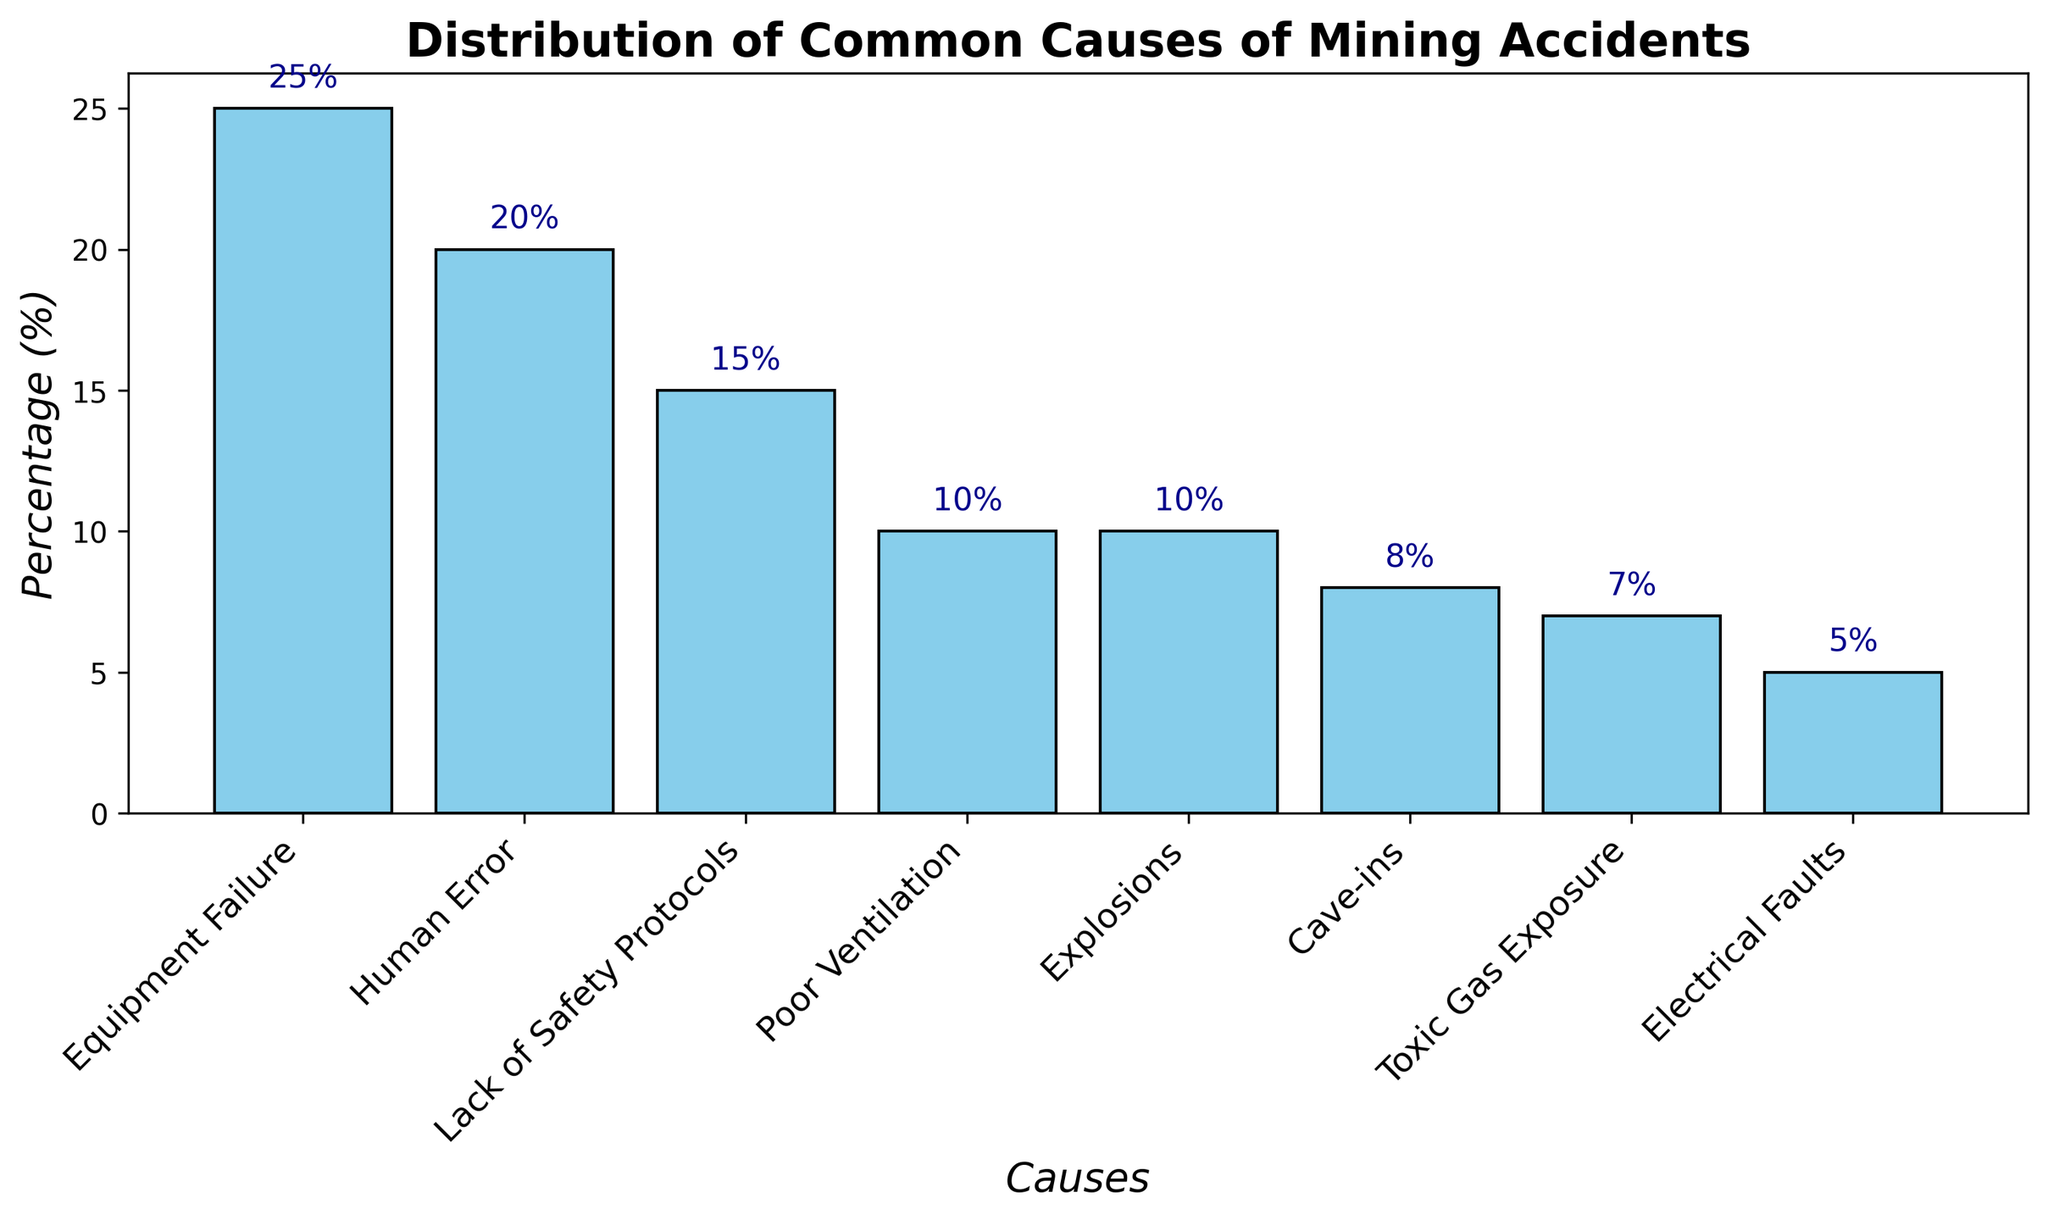Which cause has the highest percentage of mining accidents? Looking at the top of the bars, the highest bar corresponds to "Equipment Failure" with a percentage of 25%.
Answer: Equipment Failure What is the combined percentage for Poor Ventilation and Explosions? The percentage for Poor Ventilation is 10% and for Explosions is also 10%. Adding them together gives 10% + 10% = 20%.
Answer: 20% How does the percentage for Human Error compare to that for Lack of Safety Protocols? The bar representing Human Error has a height of 20%, while the bar for Lack of Safety Protocols has a height of 15%. Since 20% is greater than 15%, Human Error has a higher percentage.
Answer: Higher Which has a greater percentage: Electrical Faults or Cave-ins? The bar for Electrical Faults is 5%, while the bar for Cave-ins is 8%. Since 8% is greater than 5%, Cave-ins have a higher percentage.
Answer: Cave-ins Arrange the causes in descending order based on their percentage. Reviewing the height of the bars, we get: Equipment Failure (25%), Human Error (20%), Lack of Safety Protocols (15%), Poor Ventilation (10%), Explosions (10%), Cave-ins (8%), Toxic Gas Exposure (7%), Electrical Faults (5%).
Answer: Equipment Failure, Human Error, Lack of Safety Protocols, Poor Ventilation, Explosions, Cave-ins, Toxic Gas Exposure, Electrical Faults What is the difference in percentage between the least and the most common causes? The most common cause is Equipment Failure with 25%, and the least common is Electrical Faults with 5%. The difference is 25% - 5% = 20%.
Answer: 20% Among Human Error, Lack of Safety Protocols, and Electrical Faults, which one has the third highest percentage? Reviewing their respective percentages: Human Error (20%), Lack of Safety Protocols (15%), Electrical Faults (5%), Electrical Faults has the third highest percentage among these three.
Answer: Electrical Faults If you sum the percentages of the three least common causes, what is the total? The three least common causes are Cave-ins (8%), Toxic Gas Exposure (7%), and Electrical Faults (5%). Adding them gives 8% + 7% + 5% = 20%.
Answer: 20% What is the percentage for Explosions, and how does it compare visually to Poor Ventilation? Both Explosions and Poor Ventilation have the same height, representing a percentage of 10%.
Answer: Same What percentage of causes is attributed to Lack of Safety Protocols? Looking at the height of the respective bar, Lack of Safety Protocols has a percentage of 15%.
Answer: 15% 